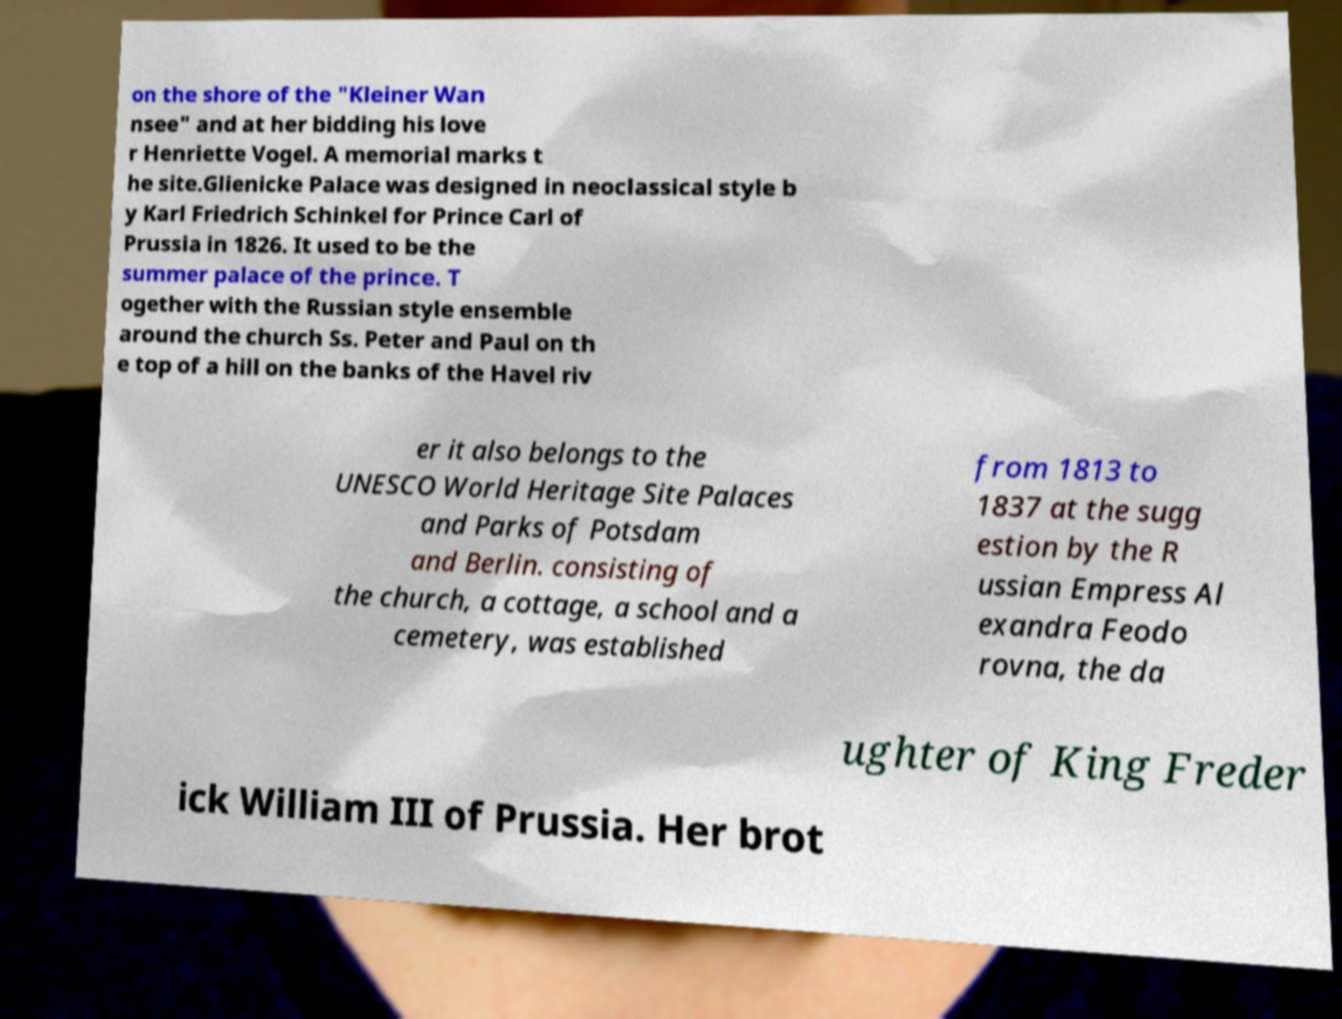Please identify and transcribe the text found in this image. on the shore of the "Kleiner Wan nsee" and at her bidding his love r Henriette Vogel. A memorial marks t he site.Glienicke Palace was designed in neoclassical style b y Karl Friedrich Schinkel for Prince Carl of Prussia in 1826. It used to be the summer palace of the prince. T ogether with the Russian style ensemble around the church Ss. Peter and Paul on th e top of a hill on the banks of the Havel riv er it also belongs to the UNESCO World Heritage Site Palaces and Parks of Potsdam and Berlin. consisting of the church, a cottage, a school and a cemetery, was established from 1813 to 1837 at the sugg estion by the R ussian Empress Al exandra Feodo rovna, the da ughter of King Freder ick William III of Prussia. Her brot 